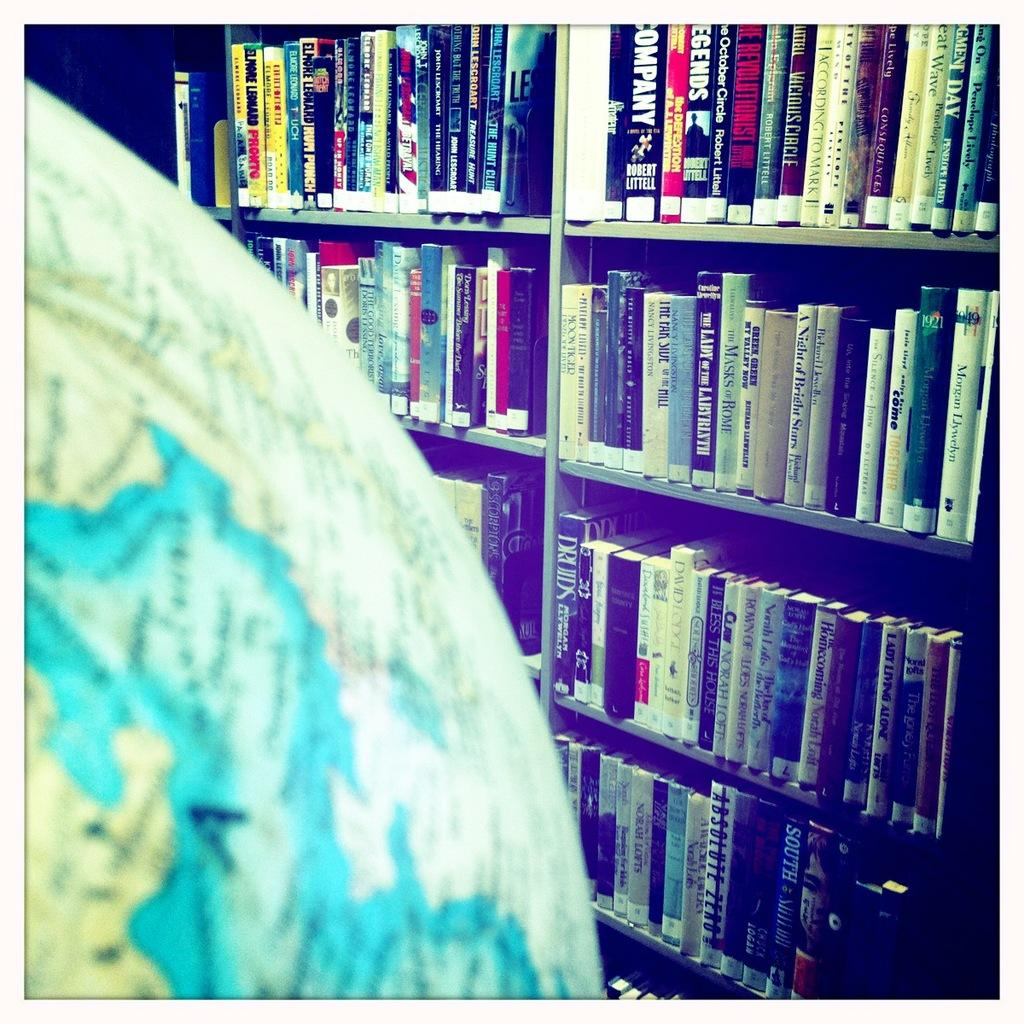Provide a one-sentence caption for the provided image. An atlas is next to a bookshelf full of books including The Lady of the Labyrinth. 